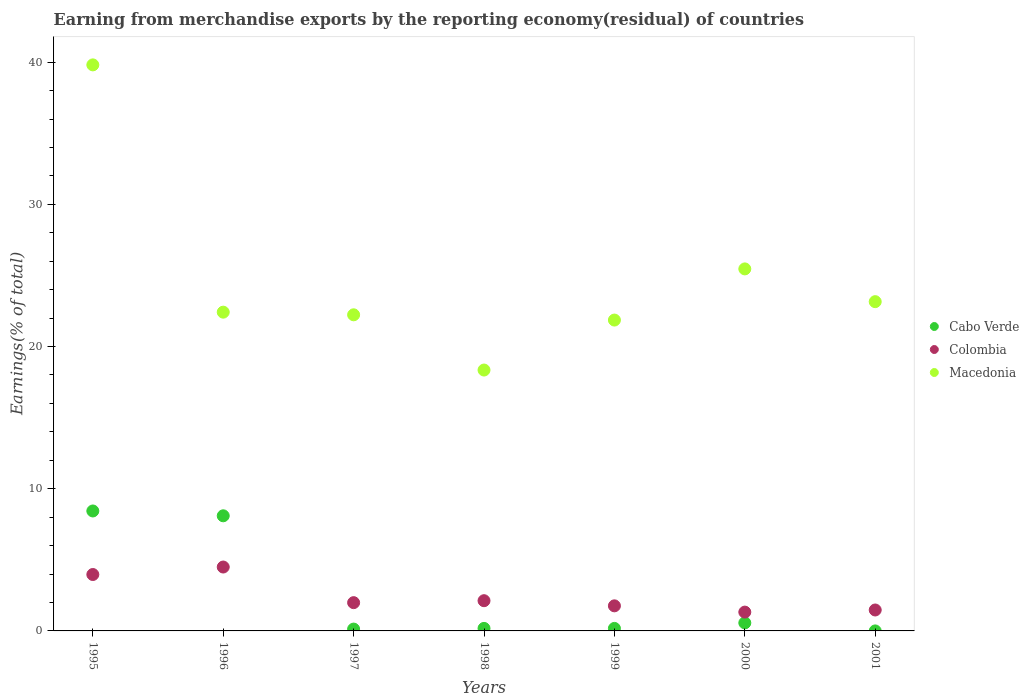How many different coloured dotlines are there?
Provide a short and direct response. 3. Is the number of dotlines equal to the number of legend labels?
Provide a succinct answer. Yes. What is the percentage of amount earned from merchandise exports in Cabo Verde in 2001?
Offer a terse response. 3.63135038739524e-9. Across all years, what is the maximum percentage of amount earned from merchandise exports in Cabo Verde?
Ensure brevity in your answer.  8.44. Across all years, what is the minimum percentage of amount earned from merchandise exports in Colombia?
Ensure brevity in your answer.  1.32. In which year was the percentage of amount earned from merchandise exports in Macedonia minimum?
Offer a terse response. 1998. What is the total percentage of amount earned from merchandise exports in Cabo Verde in the graph?
Offer a terse response. 17.58. What is the difference between the percentage of amount earned from merchandise exports in Macedonia in 1997 and that in 2001?
Keep it short and to the point. -0.92. What is the difference between the percentage of amount earned from merchandise exports in Colombia in 1995 and the percentage of amount earned from merchandise exports in Cabo Verde in 1996?
Provide a succinct answer. -4.13. What is the average percentage of amount earned from merchandise exports in Cabo Verde per year?
Your answer should be very brief. 2.51. In the year 2000, what is the difference between the percentage of amount earned from merchandise exports in Colombia and percentage of amount earned from merchandise exports in Macedonia?
Your response must be concise. -24.14. In how many years, is the percentage of amount earned from merchandise exports in Cabo Verde greater than 24 %?
Your response must be concise. 0. What is the ratio of the percentage of amount earned from merchandise exports in Cabo Verde in 1997 to that in 2001?
Offer a terse response. 3.56e+07. Is the percentage of amount earned from merchandise exports in Cabo Verde in 1999 less than that in 2000?
Make the answer very short. Yes. Is the difference between the percentage of amount earned from merchandise exports in Colombia in 1995 and 1997 greater than the difference between the percentage of amount earned from merchandise exports in Macedonia in 1995 and 1997?
Offer a terse response. No. What is the difference between the highest and the second highest percentage of amount earned from merchandise exports in Macedonia?
Your answer should be very brief. 14.35. What is the difference between the highest and the lowest percentage of amount earned from merchandise exports in Macedonia?
Your response must be concise. 21.46. Is the sum of the percentage of amount earned from merchandise exports in Macedonia in 1995 and 1996 greater than the maximum percentage of amount earned from merchandise exports in Colombia across all years?
Keep it short and to the point. Yes. Is it the case that in every year, the sum of the percentage of amount earned from merchandise exports in Cabo Verde and percentage of amount earned from merchandise exports in Macedonia  is greater than the percentage of amount earned from merchandise exports in Colombia?
Your answer should be compact. Yes. How many dotlines are there?
Make the answer very short. 3. How many years are there in the graph?
Offer a very short reply. 7. Are the values on the major ticks of Y-axis written in scientific E-notation?
Provide a short and direct response. No. How many legend labels are there?
Make the answer very short. 3. What is the title of the graph?
Provide a short and direct response. Earning from merchandise exports by the reporting economy(residual) of countries. Does "Syrian Arab Republic" appear as one of the legend labels in the graph?
Ensure brevity in your answer.  No. What is the label or title of the X-axis?
Your response must be concise. Years. What is the label or title of the Y-axis?
Give a very brief answer. Earnings(% of total). What is the Earnings(% of total) in Cabo Verde in 1995?
Your answer should be very brief. 8.44. What is the Earnings(% of total) in Colombia in 1995?
Your answer should be compact. 3.97. What is the Earnings(% of total) in Macedonia in 1995?
Make the answer very short. 39.81. What is the Earnings(% of total) in Cabo Verde in 1996?
Provide a short and direct response. 8.1. What is the Earnings(% of total) in Colombia in 1996?
Make the answer very short. 4.49. What is the Earnings(% of total) in Macedonia in 1996?
Offer a very short reply. 22.42. What is the Earnings(% of total) in Cabo Verde in 1997?
Keep it short and to the point. 0.13. What is the Earnings(% of total) of Colombia in 1997?
Provide a succinct answer. 1.99. What is the Earnings(% of total) in Macedonia in 1997?
Provide a succinct answer. 22.23. What is the Earnings(% of total) in Cabo Verde in 1998?
Your answer should be very brief. 0.18. What is the Earnings(% of total) in Colombia in 1998?
Make the answer very short. 2.13. What is the Earnings(% of total) of Macedonia in 1998?
Ensure brevity in your answer.  18.35. What is the Earnings(% of total) of Cabo Verde in 1999?
Make the answer very short. 0.18. What is the Earnings(% of total) in Colombia in 1999?
Make the answer very short. 1.76. What is the Earnings(% of total) of Macedonia in 1999?
Your answer should be compact. 21.86. What is the Earnings(% of total) in Cabo Verde in 2000?
Provide a succinct answer. 0.57. What is the Earnings(% of total) of Colombia in 2000?
Your answer should be compact. 1.32. What is the Earnings(% of total) of Macedonia in 2000?
Offer a terse response. 25.46. What is the Earnings(% of total) in Cabo Verde in 2001?
Provide a short and direct response. 3.63135038739524e-9. What is the Earnings(% of total) of Colombia in 2001?
Give a very brief answer. 1.47. What is the Earnings(% of total) in Macedonia in 2001?
Ensure brevity in your answer.  23.16. Across all years, what is the maximum Earnings(% of total) of Cabo Verde?
Ensure brevity in your answer.  8.44. Across all years, what is the maximum Earnings(% of total) of Colombia?
Make the answer very short. 4.49. Across all years, what is the maximum Earnings(% of total) in Macedonia?
Make the answer very short. 39.81. Across all years, what is the minimum Earnings(% of total) of Cabo Verde?
Provide a succinct answer. 3.63135038739524e-9. Across all years, what is the minimum Earnings(% of total) of Colombia?
Provide a succinct answer. 1.32. Across all years, what is the minimum Earnings(% of total) of Macedonia?
Provide a succinct answer. 18.35. What is the total Earnings(% of total) of Cabo Verde in the graph?
Give a very brief answer. 17.58. What is the total Earnings(% of total) in Colombia in the graph?
Ensure brevity in your answer.  17.13. What is the total Earnings(% of total) in Macedonia in the graph?
Your answer should be compact. 173.28. What is the difference between the Earnings(% of total) of Cabo Verde in 1995 and that in 1996?
Your answer should be compact. 0.34. What is the difference between the Earnings(% of total) in Colombia in 1995 and that in 1996?
Give a very brief answer. -0.53. What is the difference between the Earnings(% of total) of Macedonia in 1995 and that in 1996?
Keep it short and to the point. 17.39. What is the difference between the Earnings(% of total) of Cabo Verde in 1995 and that in 1997?
Keep it short and to the point. 8.31. What is the difference between the Earnings(% of total) in Colombia in 1995 and that in 1997?
Your answer should be very brief. 1.98. What is the difference between the Earnings(% of total) of Macedonia in 1995 and that in 1997?
Provide a succinct answer. 17.58. What is the difference between the Earnings(% of total) of Cabo Verde in 1995 and that in 1998?
Your answer should be very brief. 8.26. What is the difference between the Earnings(% of total) of Colombia in 1995 and that in 1998?
Give a very brief answer. 1.84. What is the difference between the Earnings(% of total) of Macedonia in 1995 and that in 1998?
Ensure brevity in your answer.  21.46. What is the difference between the Earnings(% of total) of Cabo Verde in 1995 and that in 1999?
Your response must be concise. 8.26. What is the difference between the Earnings(% of total) of Colombia in 1995 and that in 1999?
Provide a short and direct response. 2.2. What is the difference between the Earnings(% of total) in Macedonia in 1995 and that in 1999?
Make the answer very short. 17.95. What is the difference between the Earnings(% of total) in Cabo Verde in 1995 and that in 2000?
Your answer should be compact. 7.87. What is the difference between the Earnings(% of total) of Colombia in 1995 and that in 2000?
Your answer should be very brief. 2.64. What is the difference between the Earnings(% of total) of Macedonia in 1995 and that in 2000?
Provide a short and direct response. 14.35. What is the difference between the Earnings(% of total) in Cabo Verde in 1995 and that in 2001?
Your response must be concise. 8.44. What is the difference between the Earnings(% of total) in Colombia in 1995 and that in 2001?
Ensure brevity in your answer.  2.49. What is the difference between the Earnings(% of total) in Macedonia in 1995 and that in 2001?
Offer a very short reply. 16.65. What is the difference between the Earnings(% of total) in Cabo Verde in 1996 and that in 1997?
Provide a short and direct response. 7.97. What is the difference between the Earnings(% of total) of Colombia in 1996 and that in 1997?
Offer a terse response. 2.51. What is the difference between the Earnings(% of total) in Macedonia in 1996 and that in 1997?
Your answer should be compact. 0.19. What is the difference between the Earnings(% of total) of Cabo Verde in 1996 and that in 1998?
Give a very brief answer. 7.92. What is the difference between the Earnings(% of total) of Colombia in 1996 and that in 1998?
Provide a succinct answer. 2.37. What is the difference between the Earnings(% of total) of Macedonia in 1996 and that in 1998?
Your answer should be compact. 4.07. What is the difference between the Earnings(% of total) in Cabo Verde in 1996 and that in 1999?
Provide a short and direct response. 7.92. What is the difference between the Earnings(% of total) of Colombia in 1996 and that in 1999?
Offer a very short reply. 2.73. What is the difference between the Earnings(% of total) in Macedonia in 1996 and that in 1999?
Keep it short and to the point. 0.56. What is the difference between the Earnings(% of total) in Cabo Verde in 1996 and that in 2000?
Make the answer very short. 7.53. What is the difference between the Earnings(% of total) of Colombia in 1996 and that in 2000?
Offer a very short reply. 3.17. What is the difference between the Earnings(% of total) in Macedonia in 1996 and that in 2000?
Offer a very short reply. -3.04. What is the difference between the Earnings(% of total) of Cabo Verde in 1996 and that in 2001?
Give a very brief answer. 8.1. What is the difference between the Earnings(% of total) in Colombia in 1996 and that in 2001?
Offer a very short reply. 3.02. What is the difference between the Earnings(% of total) of Macedonia in 1996 and that in 2001?
Offer a very short reply. -0.74. What is the difference between the Earnings(% of total) in Cabo Verde in 1997 and that in 1998?
Give a very brief answer. -0.05. What is the difference between the Earnings(% of total) of Colombia in 1997 and that in 1998?
Provide a short and direct response. -0.14. What is the difference between the Earnings(% of total) of Macedonia in 1997 and that in 1998?
Give a very brief answer. 3.88. What is the difference between the Earnings(% of total) of Cabo Verde in 1997 and that in 1999?
Keep it short and to the point. -0.05. What is the difference between the Earnings(% of total) in Colombia in 1997 and that in 1999?
Make the answer very short. 0.22. What is the difference between the Earnings(% of total) in Macedonia in 1997 and that in 1999?
Make the answer very short. 0.37. What is the difference between the Earnings(% of total) of Cabo Verde in 1997 and that in 2000?
Offer a terse response. -0.44. What is the difference between the Earnings(% of total) in Colombia in 1997 and that in 2000?
Provide a succinct answer. 0.66. What is the difference between the Earnings(% of total) in Macedonia in 1997 and that in 2000?
Your answer should be very brief. -3.23. What is the difference between the Earnings(% of total) of Cabo Verde in 1997 and that in 2001?
Offer a very short reply. 0.13. What is the difference between the Earnings(% of total) of Colombia in 1997 and that in 2001?
Give a very brief answer. 0.52. What is the difference between the Earnings(% of total) of Macedonia in 1997 and that in 2001?
Provide a short and direct response. -0.92. What is the difference between the Earnings(% of total) in Cabo Verde in 1998 and that in 1999?
Your response must be concise. 0. What is the difference between the Earnings(% of total) in Colombia in 1998 and that in 1999?
Keep it short and to the point. 0.36. What is the difference between the Earnings(% of total) in Macedonia in 1998 and that in 1999?
Offer a terse response. -3.51. What is the difference between the Earnings(% of total) in Cabo Verde in 1998 and that in 2000?
Ensure brevity in your answer.  -0.39. What is the difference between the Earnings(% of total) of Colombia in 1998 and that in 2000?
Ensure brevity in your answer.  0.8. What is the difference between the Earnings(% of total) of Macedonia in 1998 and that in 2000?
Keep it short and to the point. -7.11. What is the difference between the Earnings(% of total) in Cabo Verde in 1998 and that in 2001?
Provide a short and direct response. 0.18. What is the difference between the Earnings(% of total) of Colombia in 1998 and that in 2001?
Keep it short and to the point. 0.65. What is the difference between the Earnings(% of total) in Macedonia in 1998 and that in 2001?
Your answer should be very brief. -4.81. What is the difference between the Earnings(% of total) of Cabo Verde in 1999 and that in 2000?
Offer a terse response. -0.39. What is the difference between the Earnings(% of total) of Colombia in 1999 and that in 2000?
Ensure brevity in your answer.  0.44. What is the difference between the Earnings(% of total) of Macedonia in 1999 and that in 2000?
Your response must be concise. -3.6. What is the difference between the Earnings(% of total) in Cabo Verde in 1999 and that in 2001?
Provide a short and direct response. 0.18. What is the difference between the Earnings(% of total) in Colombia in 1999 and that in 2001?
Provide a succinct answer. 0.29. What is the difference between the Earnings(% of total) in Macedonia in 1999 and that in 2001?
Give a very brief answer. -1.29. What is the difference between the Earnings(% of total) in Cabo Verde in 2000 and that in 2001?
Provide a short and direct response. 0.57. What is the difference between the Earnings(% of total) of Colombia in 2000 and that in 2001?
Provide a short and direct response. -0.15. What is the difference between the Earnings(% of total) in Macedonia in 2000 and that in 2001?
Offer a very short reply. 2.3. What is the difference between the Earnings(% of total) in Cabo Verde in 1995 and the Earnings(% of total) in Colombia in 1996?
Provide a short and direct response. 3.94. What is the difference between the Earnings(% of total) in Cabo Verde in 1995 and the Earnings(% of total) in Macedonia in 1996?
Ensure brevity in your answer.  -13.98. What is the difference between the Earnings(% of total) of Colombia in 1995 and the Earnings(% of total) of Macedonia in 1996?
Offer a very short reply. -18.45. What is the difference between the Earnings(% of total) in Cabo Verde in 1995 and the Earnings(% of total) in Colombia in 1997?
Keep it short and to the point. 6.45. What is the difference between the Earnings(% of total) of Cabo Verde in 1995 and the Earnings(% of total) of Macedonia in 1997?
Make the answer very short. -13.8. What is the difference between the Earnings(% of total) of Colombia in 1995 and the Earnings(% of total) of Macedonia in 1997?
Offer a terse response. -18.26. What is the difference between the Earnings(% of total) of Cabo Verde in 1995 and the Earnings(% of total) of Colombia in 1998?
Provide a succinct answer. 6.31. What is the difference between the Earnings(% of total) of Cabo Verde in 1995 and the Earnings(% of total) of Macedonia in 1998?
Provide a short and direct response. -9.91. What is the difference between the Earnings(% of total) of Colombia in 1995 and the Earnings(% of total) of Macedonia in 1998?
Your response must be concise. -14.38. What is the difference between the Earnings(% of total) of Cabo Verde in 1995 and the Earnings(% of total) of Colombia in 1999?
Your answer should be very brief. 6.67. What is the difference between the Earnings(% of total) of Cabo Verde in 1995 and the Earnings(% of total) of Macedonia in 1999?
Ensure brevity in your answer.  -13.43. What is the difference between the Earnings(% of total) in Colombia in 1995 and the Earnings(% of total) in Macedonia in 1999?
Offer a terse response. -17.89. What is the difference between the Earnings(% of total) in Cabo Verde in 1995 and the Earnings(% of total) in Colombia in 2000?
Give a very brief answer. 7.11. What is the difference between the Earnings(% of total) of Cabo Verde in 1995 and the Earnings(% of total) of Macedonia in 2000?
Offer a very short reply. -17.02. What is the difference between the Earnings(% of total) in Colombia in 1995 and the Earnings(% of total) in Macedonia in 2000?
Provide a succinct answer. -21.49. What is the difference between the Earnings(% of total) of Cabo Verde in 1995 and the Earnings(% of total) of Colombia in 2001?
Offer a very short reply. 6.96. What is the difference between the Earnings(% of total) of Cabo Verde in 1995 and the Earnings(% of total) of Macedonia in 2001?
Offer a very short reply. -14.72. What is the difference between the Earnings(% of total) in Colombia in 1995 and the Earnings(% of total) in Macedonia in 2001?
Provide a succinct answer. -19.19. What is the difference between the Earnings(% of total) of Cabo Verde in 1996 and the Earnings(% of total) of Colombia in 1997?
Offer a very short reply. 6.11. What is the difference between the Earnings(% of total) of Cabo Verde in 1996 and the Earnings(% of total) of Macedonia in 1997?
Your answer should be compact. -14.13. What is the difference between the Earnings(% of total) of Colombia in 1996 and the Earnings(% of total) of Macedonia in 1997?
Give a very brief answer. -17.74. What is the difference between the Earnings(% of total) in Cabo Verde in 1996 and the Earnings(% of total) in Colombia in 1998?
Your response must be concise. 5.97. What is the difference between the Earnings(% of total) of Cabo Verde in 1996 and the Earnings(% of total) of Macedonia in 1998?
Your answer should be compact. -10.25. What is the difference between the Earnings(% of total) in Colombia in 1996 and the Earnings(% of total) in Macedonia in 1998?
Ensure brevity in your answer.  -13.85. What is the difference between the Earnings(% of total) of Cabo Verde in 1996 and the Earnings(% of total) of Colombia in 1999?
Keep it short and to the point. 6.33. What is the difference between the Earnings(% of total) in Cabo Verde in 1996 and the Earnings(% of total) in Macedonia in 1999?
Provide a succinct answer. -13.77. What is the difference between the Earnings(% of total) in Colombia in 1996 and the Earnings(% of total) in Macedonia in 1999?
Ensure brevity in your answer.  -17.37. What is the difference between the Earnings(% of total) in Cabo Verde in 1996 and the Earnings(% of total) in Colombia in 2000?
Ensure brevity in your answer.  6.77. What is the difference between the Earnings(% of total) of Cabo Verde in 1996 and the Earnings(% of total) of Macedonia in 2000?
Make the answer very short. -17.36. What is the difference between the Earnings(% of total) of Colombia in 1996 and the Earnings(% of total) of Macedonia in 2000?
Provide a short and direct response. -20.97. What is the difference between the Earnings(% of total) of Cabo Verde in 1996 and the Earnings(% of total) of Colombia in 2001?
Offer a very short reply. 6.62. What is the difference between the Earnings(% of total) of Cabo Verde in 1996 and the Earnings(% of total) of Macedonia in 2001?
Your answer should be compact. -15.06. What is the difference between the Earnings(% of total) in Colombia in 1996 and the Earnings(% of total) in Macedonia in 2001?
Make the answer very short. -18.66. What is the difference between the Earnings(% of total) in Cabo Verde in 1997 and the Earnings(% of total) in Colombia in 1998?
Your answer should be compact. -2. What is the difference between the Earnings(% of total) in Cabo Verde in 1997 and the Earnings(% of total) in Macedonia in 1998?
Give a very brief answer. -18.22. What is the difference between the Earnings(% of total) in Colombia in 1997 and the Earnings(% of total) in Macedonia in 1998?
Offer a very short reply. -16.36. What is the difference between the Earnings(% of total) in Cabo Verde in 1997 and the Earnings(% of total) in Colombia in 1999?
Give a very brief answer. -1.63. What is the difference between the Earnings(% of total) of Cabo Verde in 1997 and the Earnings(% of total) of Macedonia in 1999?
Make the answer very short. -21.73. What is the difference between the Earnings(% of total) in Colombia in 1997 and the Earnings(% of total) in Macedonia in 1999?
Your answer should be very brief. -19.87. What is the difference between the Earnings(% of total) in Cabo Verde in 1997 and the Earnings(% of total) in Colombia in 2000?
Your answer should be compact. -1.19. What is the difference between the Earnings(% of total) in Cabo Verde in 1997 and the Earnings(% of total) in Macedonia in 2000?
Ensure brevity in your answer.  -25.33. What is the difference between the Earnings(% of total) of Colombia in 1997 and the Earnings(% of total) of Macedonia in 2000?
Provide a short and direct response. -23.47. What is the difference between the Earnings(% of total) in Cabo Verde in 1997 and the Earnings(% of total) in Colombia in 2001?
Offer a terse response. -1.34. What is the difference between the Earnings(% of total) of Cabo Verde in 1997 and the Earnings(% of total) of Macedonia in 2001?
Ensure brevity in your answer.  -23.03. What is the difference between the Earnings(% of total) of Colombia in 1997 and the Earnings(% of total) of Macedonia in 2001?
Your answer should be compact. -21.17. What is the difference between the Earnings(% of total) of Cabo Verde in 1998 and the Earnings(% of total) of Colombia in 1999?
Your response must be concise. -1.59. What is the difference between the Earnings(% of total) of Cabo Verde in 1998 and the Earnings(% of total) of Macedonia in 1999?
Offer a terse response. -21.68. What is the difference between the Earnings(% of total) in Colombia in 1998 and the Earnings(% of total) in Macedonia in 1999?
Ensure brevity in your answer.  -19.74. What is the difference between the Earnings(% of total) of Cabo Verde in 1998 and the Earnings(% of total) of Colombia in 2000?
Your answer should be very brief. -1.15. What is the difference between the Earnings(% of total) of Cabo Verde in 1998 and the Earnings(% of total) of Macedonia in 2000?
Your response must be concise. -25.28. What is the difference between the Earnings(% of total) in Colombia in 1998 and the Earnings(% of total) in Macedonia in 2000?
Give a very brief answer. -23.33. What is the difference between the Earnings(% of total) of Cabo Verde in 1998 and the Earnings(% of total) of Colombia in 2001?
Offer a terse response. -1.29. What is the difference between the Earnings(% of total) in Cabo Verde in 1998 and the Earnings(% of total) in Macedonia in 2001?
Provide a short and direct response. -22.98. What is the difference between the Earnings(% of total) in Colombia in 1998 and the Earnings(% of total) in Macedonia in 2001?
Provide a short and direct response. -21.03. What is the difference between the Earnings(% of total) in Cabo Verde in 1999 and the Earnings(% of total) in Colombia in 2000?
Make the answer very short. -1.15. What is the difference between the Earnings(% of total) of Cabo Verde in 1999 and the Earnings(% of total) of Macedonia in 2000?
Offer a very short reply. -25.28. What is the difference between the Earnings(% of total) in Colombia in 1999 and the Earnings(% of total) in Macedonia in 2000?
Keep it short and to the point. -23.7. What is the difference between the Earnings(% of total) of Cabo Verde in 1999 and the Earnings(% of total) of Colombia in 2001?
Provide a short and direct response. -1.3. What is the difference between the Earnings(% of total) in Cabo Verde in 1999 and the Earnings(% of total) in Macedonia in 2001?
Offer a terse response. -22.98. What is the difference between the Earnings(% of total) of Colombia in 1999 and the Earnings(% of total) of Macedonia in 2001?
Offer a terse response. -21.39. What is the difference between the Earnings(% of total) of Cabo Verde in 2000 and the Earnings(% of total) of Colombia in 2001?
Make the answer very short. -0.91. What is the difference between the Earnings(% of total) in Cabo Verde in 2000 and the Earnings(% of total) in Macedonia in 2001?
Keep it short and to the point. -22.59. What is the difference between the Earnings(% of total) of Colombia in 2000 and the Earnings(% of total) of Macedonia in 2001?
Give a very brief answer. -21.83. What is the average Earnings(% of total) in Cabo Verde per year?
Keep it short and to the point. 2.51. What is the average Earnings(% of total) of Colombia per year?
Your answer should be very brief. 2.45. What is the average Earnings(% of total) in Macedonia per year?
Keep it short and to the point. 24.75. In the year 1995, what is the difference between the Earnings(% of total) of Cabo Verde and Earnings(% of total) of Colombia?
Your answer should be compact. 4.47. In the year 1995, what is the difference between the Earnings(% of total) of Cabo Verde and Earnings(% of total) of Macedonia?
Provide a succinct answer. -31.37. In the year 1995, what is the difference between the Earnings(% of total) in Colombia and Earnings(% of total) in Macedonia?
Keep it short and to the point. -35.84. In the year 1996, what is the difference between the Earnings(% of total) in Cabo Verde and Earnings(% of total) in Colombia?
Provide a succinct answer. 3.6. In the year 1996, what is the difference between the Earnings(% of total) in Cabo Verde and Earnings(% of total) in Macedonia?
Give a very brief answer. -14.32. In the year 1996, what is the difference between the Earnings(% of total) of Colombia and Earnings(% of total) of Macedonia?
Give a very brief answer. -17.92. In the year 1997, what is the difference between the Earnings(% of total) in Cabo Verde and Earnings(% of total) in Colombia?
Your answer should be very brief. -1.86. In the year 1997, what is the difference between the Earnings(% of total) of Cabo Verde and Earnings(% of total) of Macedonia?
Offer a very short reply. -22.1. In the year 1997, what is the difference between the Earnings(% of total) of Colombia and Earnings(% of total) of Macedonia?
Offer a very short reply. -20.24. In the year 1998, what is the difference between the Earnings(% of total) in Cabo Verde and Earnings(% of total) in Colombia?
Make the answer very short. -1.95. In the year 1998, what is the difference between the Earnings(% of total) of Cabo Verde and Earnings(% of total) of Macedonia?
Give a very brief answer. -18.17. In the year 1998, what is the difference between the Earnings(% of total) of Colombia and Earnings(% of total) of Macedonia?
Ensure brevity in your answer.  -16.22. In the year 1999, what is the difference between the Earnings(% of total) of Cabo Verde and Earnings(% of total) of Colombia?
Offer a terse response. -1.59. In the year 1999, what is the difference between the Earnings(% of total) in Cabo Verde and Earnings(% of total) in Macedonia?
Keep it short and to the point. -21.68. In the year 1999, what is the difference between the Earnings(% of total) in Colombia and Earnings(% of total) in Macedonia?
Offer a terse response. -20.1. In the year 2000, what is the difference between the Earnings(% of total) in Cabo Verde and Earnings(% of total) in Colombia?
Keep it short and to the point. -0.76. In the year 2000, what is the difference between the Earnings(% of total) of Cabo Verde and Earnings(% of total) of Macedonia?
Offer a terse response. -24.89. In the year 2000, what is the difference between the Earnings(% of total) of Colombia and Earnings(% of total) of Macedonia?
Your response must be concise. -24.14. In the year 2001, what is the difference between the Earnings(% of total) in Cabo Verde and Earnings(% of total) in Colombia?
Provide a succinct answer. -1.47. In the year 2001, what is the difference between the Earnings(% of total) in Cabo Verde and Earnings(% of total) in Macedonia?
Your answer should be very brief. -23.16. In the year 2001, what is the difference between the Earnings(% of total) in Colombia and Earnings(% of total) in Macedonia?
Offer a terse response. -21.68. What is the ratio of the Earnings(% of total) in Cabo Verde in 1995 to that in 1996?
Keep it short and to the point. 1.04. What is the ratio of the Earnings(% of total) in Colombia in 1995 to that in 1996?
Offer a terse response. 0.88. What is the ratio of the Earnings(% of total) in Macedonia in 1995 to that in 1996?
Keep it short and to the point. 1.78. What is the ratio of the Earnings(% of total) in Cabo Verde in 1995 to that in 1997?
Make the answer very short. 65.24. What is the ratio of the Earnings(% of total) of Colombia in 1995 to that in 1997?
Ensure brevity in your answer.  2. What is the ratio of the Earnings(% of total) in Macedonia in 1995 to that in 1997?
Ensure brevity in your answer.  1.79. What is the ratio of the Earnings(% of total) in Cabo Verde in 1995 to that in 1998?
Offer a very short reply. 47.5. What is the ratio of the Earnings(% of total) in Colombia in 1995 to that in 1998?
Offer a terse response. 1.87. What is the ratio of the Earnings(% of total) of Macedonia in 1995 to that in 1998?
Offer a terse response. 2.17. What is the ratio of the Earnings(% of total) of Cabo Verde in 1995 to that in 1999?
Ensure brevity in your answer.  47.67. What is the ratio of the Earnings(% of total) in Colombia in 1995 to that in 1999?
Provide a short and direct response. 2.25. What is the ratio of the Earnings(% of total) of Macedonia in 1995 to that in 1999?
Give a very brief answer. 1.82. What is the ratio of the Earnings(% of total) in Cabo Verde in 1995 to that in 2000?
Your response must be concise. 14.93. What is the ratio of the Earnings(% of total) of Colombia in 1995 to that in 2000?
Your answer should be compact. 3. What is the ratio of the Earnings(% of total) of Macedonia in 1995 to that in 2000?
Offer a very short reply. 1.56. What is the ratio of the Earnings(% of total) of Cabo Verde in 1995 to that in 2001?
Your response must be concise. 2.32e+09. What is the ratio of the Earnings(% of total) of Colombia in 1995 to that in 2001?
Provide a succinct answer. 2.69. What is the ratio of the Earnings(% of total) in Macedonia in 1995 to that in 2001?
Provide a short and direct response. 1.72. What is the ratio of the Earnings(% of total) of Cabo Verde in 1996 to that in 1997?
Make the answer very short. 62.61. What is the ratio of the Earnings(% of total) in Colombia in 1996 to that in 1997?
Provide a succinct answer. 2.26. What is the ratio of the Earnings(% of total) in Macedonia in 1996 to that in 1997?
Offer a terse response. 1.01. What is the ratio of the Earnings(% of total) of Cabo Verde in 1996 to that in 1998?
Provide a short and direct response. 45.59. What is the ratio of the Earnings(% of total) of Colombia in 1996 to that in 1998?
Provide a succinct answer. 2.11. What is the ratio of the Earnings(% of total) in Macedonia in 1996 to that in 1998?
Offer a very short reply. 1.22. What is the ratio of the Earnings(% of total) in Cabo Verde in 1996 to that in 1999?
Ensure brevity in your answer.  45.75. What is the ratio of the Earnings(% of total) in Colombia in 1996 to that in 1999?
Ensure brevity in your answer.  2.55. What is the ratio of the Earnings(% of total) in Macedonia in 1996 to that in 1999?
Make the answer very short. 1.03. What is the ratio of the Earnings(% of total) of Cabo Verde in 1996 to that in 2000?
Keep it short and to the point. 14.33. What is the ratio of the Earnings(% of total) in Colombia in 1996 to that in 2000?
Keep it short and to the point. 3.4. What is the ratio of the Earnings(% of total) in Macedonia in 1996 to that in 2000?
Make the answer very short. 0.88. What is the ratio of the Earnings(% of total) in Cabo Verde in 1996 to that in 2001?
Make the answer very short. 2.23e+09. What is the ratio of the Earnings(% of total) in Colombia in 1996 to that in 2001?
Keep it short and to the point. 3.05. What is the ratio of the Earnings(% of total) of Macedonia in 1996 to that in 2001?
Provide a short and direct response. 0.97. What is the ratio of the Earnings(% of total) in Cabo Verde in 1997 to that in 1998?
Offer a terse response. 0.73. What is the ratio of the Earnings(% of total) of Colombia in 1997 to that in 1998?
Offer a very short reply. 0.94. What is the ratio of the Earnings(% of total) of Macedonia in 1997 to that in 1998?
Provide a short and direct response. 1.21. What is the ratio of the Earnings(% of total) in Cabo Verde in 1997 to that in 1999?
Ensure brevity in your answer.  0.73. What is the ratio of the Earnings(% of total) in Colombia in 1997 to that in 1999?
Your answer should be compact. 1.13. What is the ratio of the Earnings(% of total) in Macedonia in 1997 to that in 1999?
Keep it short and to the point. 1.02. What is the ratio of the Earnings(% of total) of Cabo Verde in 1997 to that in 2000?
Offer a very short reply. 0.23. What is the ratio of the Earnings(% of total) in Colombia in 1997 to that in 2000?
Give a very brief answer. 1.5. What is the ratio of the Earnings(% of total) of Macedonia in 1997 to that in 2000?
Provide a short and direct response. 0.87. What is the ratio of the Earnings(% of total) in Cabo Verde in 1997 to that in 2001?
Keep it short and to the point. 3.56e+07. What is the ratio of the Earnings(% of total) of Colombia in 1997 to that in 2001?
Offer a very short reply. 1.35. What is the ratio of the Earnings(% of total) in Macedonia in 1997 to that in 2001?
Your answer should be very brief. 0.96. What is the ratio of the Earnings(% of total) of Colombia in 1998 to that in 1999?
Give a very brief answer. 1.21. What is the ratio of the Earnings(% of total) of Macedonia in 1998 to that in 1999?
Your response must be concise. 0.84. What is the ratio of the Earnings(% of total) in Cabo Verde in 1998 to that in 2000?
Your response must be concise. 0.31. What is the ratio of the Earnings(% of total) of Colombia in 1998 to that in 2000?
Offer a very short reply. 1.61. What is the ratio of the Earnings(% of total) of Macedonia in 1998 to that in 2000?
Offer a terse response. 0.72. What is the ratio of the Earnings(% of total) of Cabo Verde in 1998 to that in 2001?
Ensure brevity in your answer.  4.89e+07. What is the ratio of the Earnings(% of total) in Colombia in 1998 to that in 2001?
Provide a succinct answer. 1.44. What is the ratio of the Earnings(% of total) in Macedonia in 1998 to that in 2001?
Offer a terse response. 0.79. What is the ratio of the Earnings(% of total) in Cabo Verde in 1999 to that in 2000?
Keep it short and to the point. 0.31. What is the ratio of the Earnings(% of total) in Colombia in 1999 to that in 2000?
Ensure brevity in your answer.  1.33. What is the ratio of the Earnings(% of total) of Macedonia in 1999 to that in 2000?
Offer a terse response. 0.86. What is the ratio of the Earnings(% of total) in Cabo Verde in 1999 to that in 2001?
Provide a short and direct response. 4.87e+07. What is the ratio of the Earnings(% of total) of Colombia in 1999 to that in 2001?
Ensure brevity in your answer.  1.2. What is the ratio of the Earnings(% of total) of Macedonia in 1999 to that in 2001?
Make the answer very short. 0.94. What is the ratio of the Earnings(% of total) in Cabo Verde in 2000 to that in 2001?
Offer a terse response. 1.56e+08. What is the ratio of the Earnings(% of total) in Colombia in 2000 to that in 2001?
Your answer should be compact. 0.9. What is the ratio of the Earnings(% of total) of Macedonia in 2000 to that in 2001?
Your answer should be compact. 1.1. What is the difference between the highest and the second highest Earnings(% of total) of Cabo Verde?
Your answer should be very brief. 0.34. What is the difference between the highest and the second highest Earnings(% of total) of Colombia?
Your answer should be compact. 0.53. What is the difference between the highest and the second highest Earnings(% of total) of Macedonia?
Your answer should be compact. 14.35. What is the difference between the highest and the lowest Earnings(% of total) of Cabo Verde?
Keep it short and to the point. 8.44. What is the difference between the highest and the lowest Earnings(% of total) of Colombia?
Provide a short and direct response. 3.17. What is the difference between the highest and the lowest Earnings(% of total) in Macedonia?
Your answer should be compact. 21.46. 